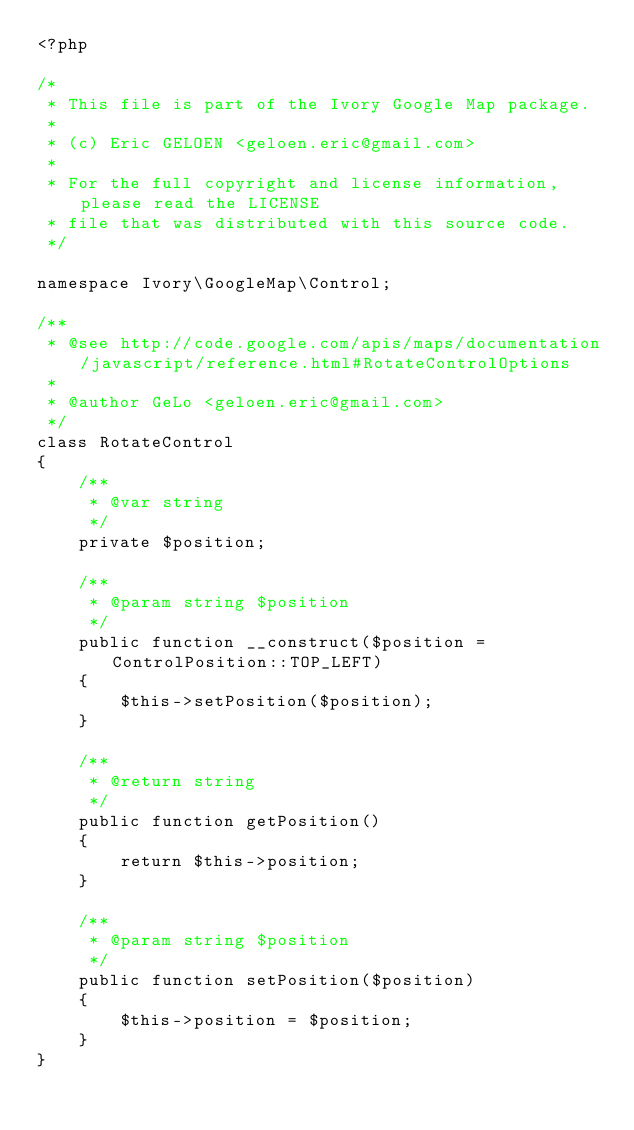<code> <loc_0><loc_0><loc_500><loc_500><_PHP_><?php

/*
 * This file is part of the Ivory Google Map package.
 *
 * (c) Eric GELOEN <geloen.eric@gmail.com>
 *
 * For the full copyright and license information, please read the LICENSE
 * file that was distributed with this source code.
 */

namespace Ivory\GoogleMap\Control;

/**
 * @see http://code.google.com/apis/maps/documentation/javascript/reference.html#RotateControlOptions
 *
 * @author GeLo <geloen.eric@gmail.com>
 */
class RotateControl
{
    /**
     * @var string
     */
    private $position;

    /**
     * @param string $position
     */
    public function __construct($position = ControlPosition::TOP_LEFT)
    {
        $this->setPosition($position);
    }

    /**
     * @return string
     */
    public function getPosition()
    {
        return $this->position;
    }

    /**
     * @param string $position
     */
    public function setPosition($position)
    {
        $this->position = $position;
    }
}
</code> 